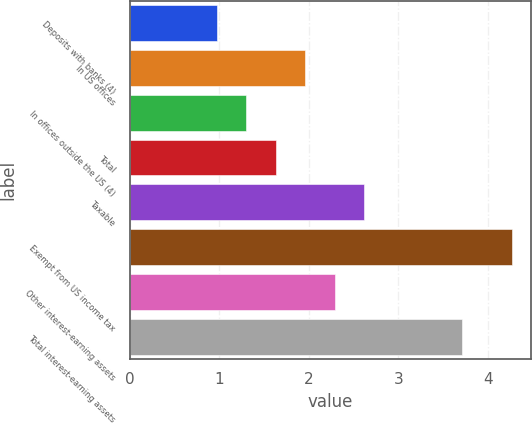<chart> <loc_0><loc_0><loc_500><loc_500><bar_chart><fcel>Deposits with banks (4)<fcel>In US offices<fcel>In offices outside the US (4)<fcel>Total<fcel>Taxable<fcel>Exempt from US income tax<fcel>Other interest-earning assets<fcel>Total interest-earning assets<nl><fcel>0.97<fcel>1.96<fcel>1.3<fcel>1.63<fcel>2.62<fcel>4.27<fcel>2.29<fcel>3.71<nl></chart> 